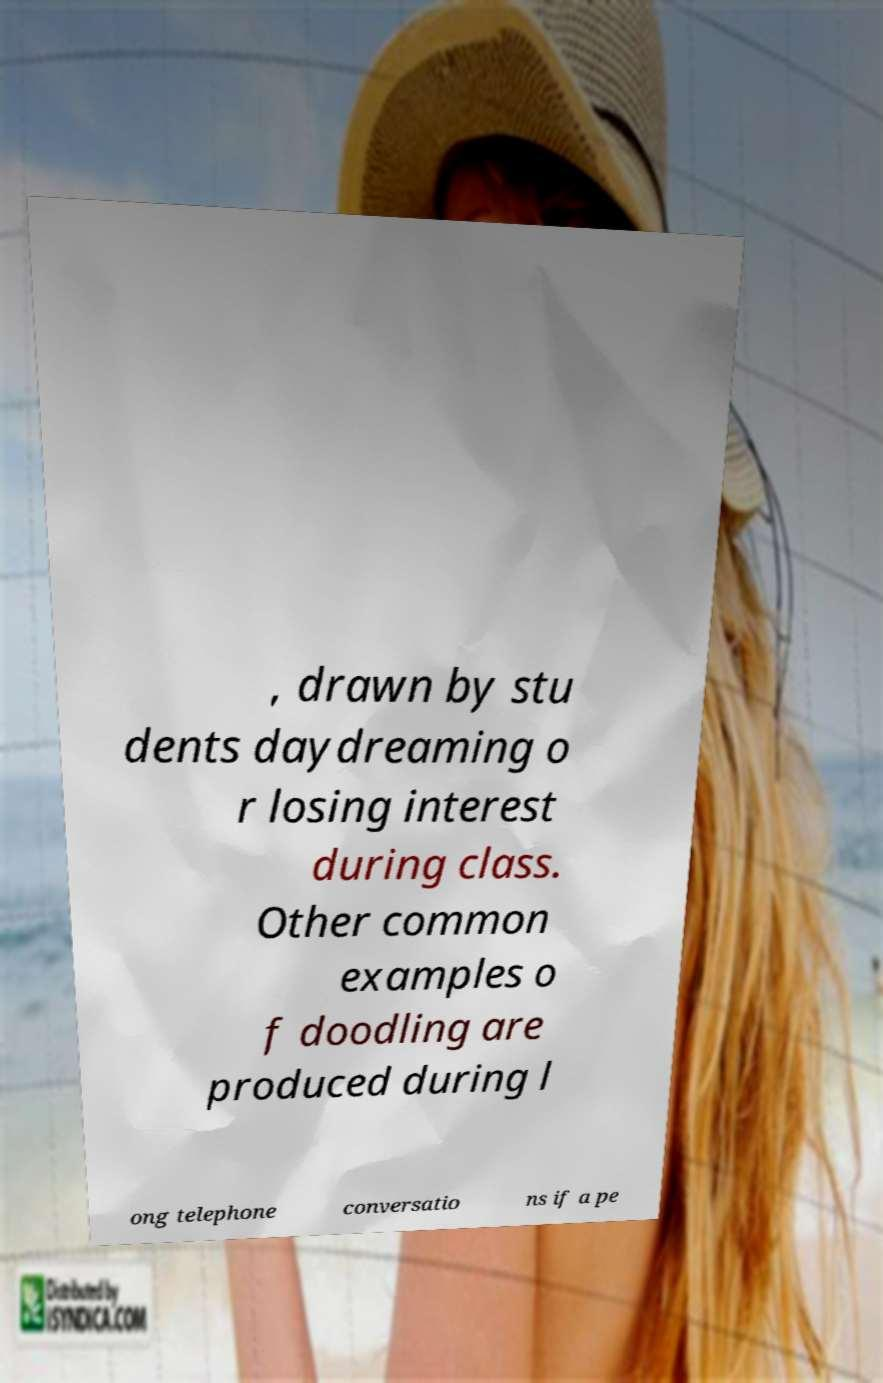Can you read and provide the text displayed in the image?This photo seems to have some interesting text. Can you extract and type it out for me? , drawn by stu dents daydreaming o r losing interest during class. Other common examples o f doodling are produced during l ong telephone conversatio ns if a pe 